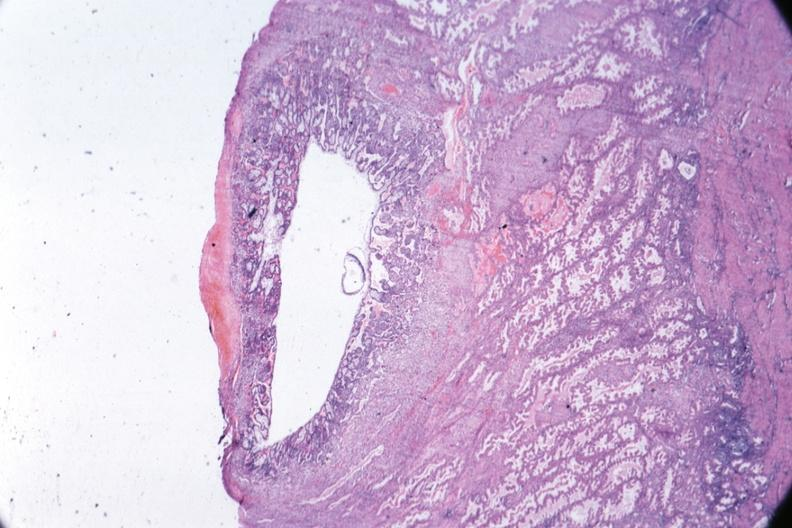s uterus present?
Answer the question using a single word or phrase. Yes 